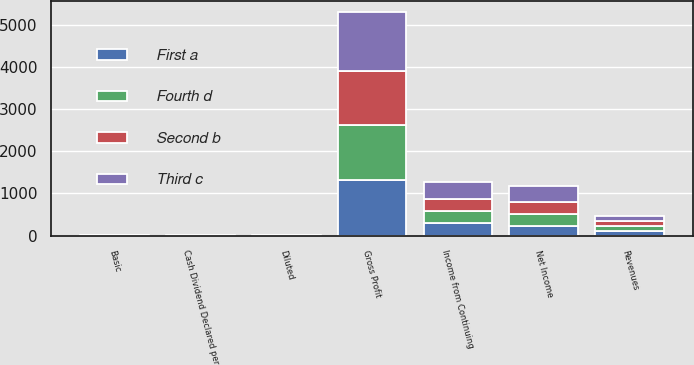<chart> <loc_0><loc_0><loc_500><loc_500><stacked_bar_chart><ecel><fcel>Revenues<fcel>Gross Profit<fcel>Income from Continuing<fcel>Net Income<fcel>Basic<fcel>Diluted<fcel>Cash Dividend Declared per<nl><fcel>Fourth d<fcel>117.44<fcel>1289.7<fcel>280.8<fcel>277.3<fcel>0.76<fcel>0.76<fcel>0.13<nl><fcel>First a<fcel>117.44<fcel>1321.3<fcel>292.4<fcel>233.8<fcel>0.8<fcel>0.79<fcel>0.13<nl><fcel>Second b<fcel>117.44<fcel>1298.4<fcel>299.4<fcel>290.4<fcel>0.83<fcel>0.82<fcel>0.13<nl><fcel>Third c<fcel>117.44<fcel>1386.1<fcel>385.8<fcel>376.4<fcel>1.08<fcel>1.07<fcel>0.15<nl></chart> 